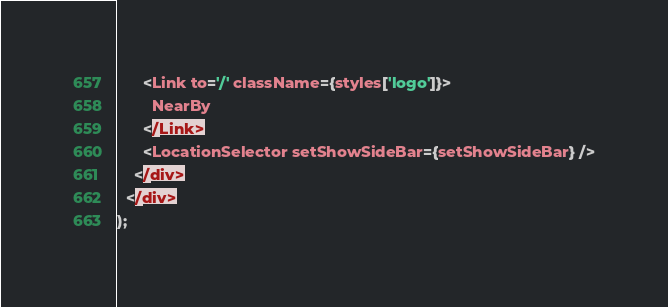Convert code to text. <code><loc_0><loc_0><loc_500><loc_500><_JavaScript_>      <Link to='/' className={styles['logo']}>
        NearBy
      </Link>
      <LocationSelector setShowSideBar={setShowSideBar} />
    </div>
  </div>
);
</code> 